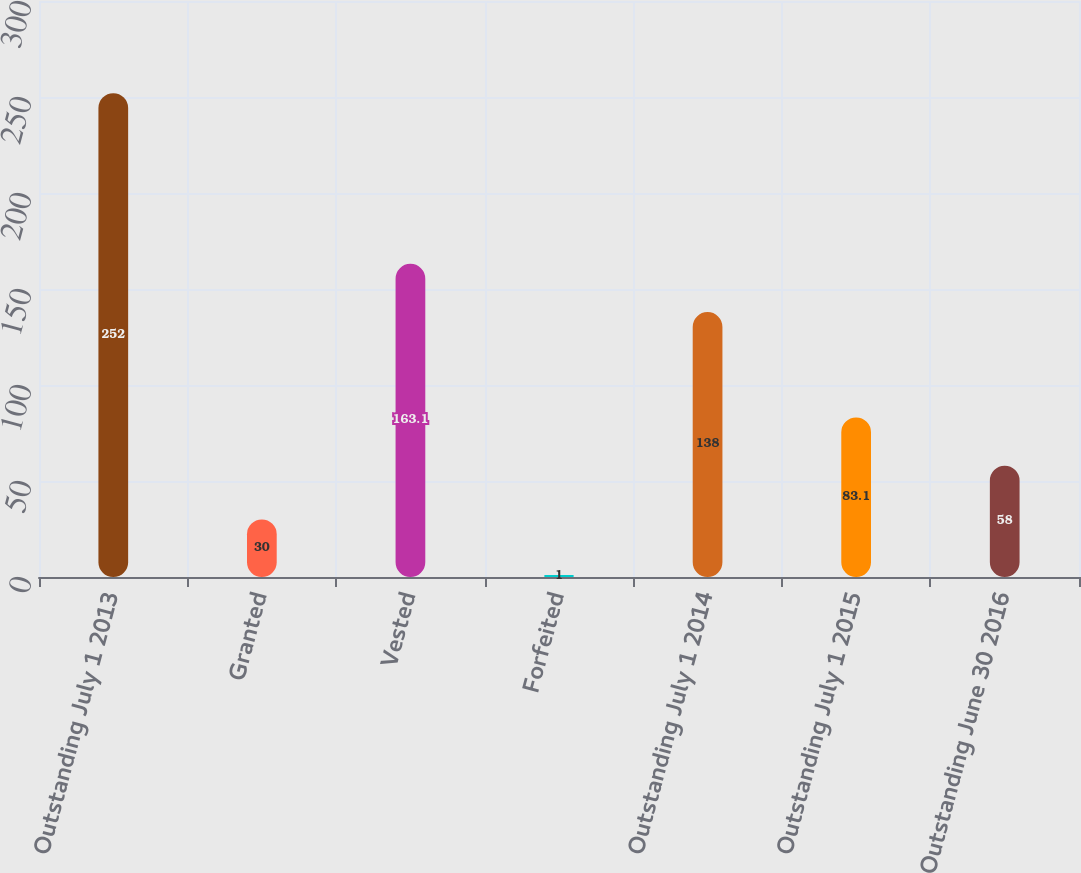<chart> <loc_0><loc_0><loc_500><loc_500><bar_chart><fcel>Outstanding July 1 2013<fcel>Granted<fcel>Vested<fcel>Forfeited<fcel>Outstanding July 1 2014<fcel>Outstanding July 1 2015<fcel>Outstanding June 30 2016<nl><fcel>252<fcel>30<fcel>163.1<fcel>1<fcel>138<fcel>83.1<fcel>58<nl></chart> 